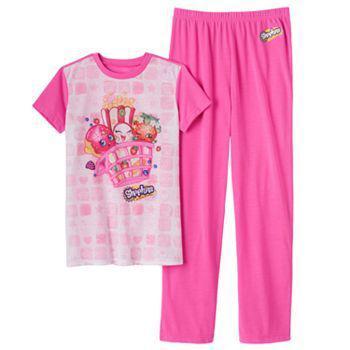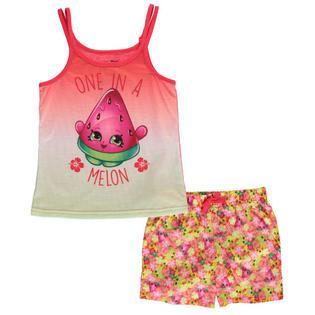The first image is the image on the left, the second image is the image on the right. Considering the images on both sides, is "a pair of pajamas has short sleeves and long pants" valid? Answer yes or no. Yes. The first image is the image on the left, the second image is the image on the right. Considering the images on both sides, is "There is one pair of shorts and one pair of pants." valid? Answer yes or no. Yes. 